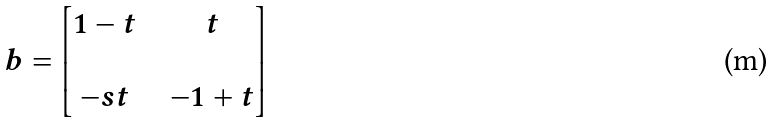<formula> <loc_0><loc_0><loc_500><loc_500>b = \begin{bmatrix} 1 - t & & t \\ & & \\ - s t & & - 1 + t \end{bmatrix}</formula> 